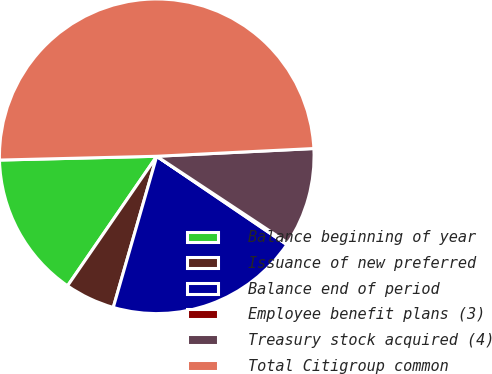Convert chart. <chart><loc_0><loc_0><loc_500><loc_500><pie_chart><fcel>Balance beginning of year<fcel>Issuance of new preferred<fcel>Balance end of period<fcel>Employee benefit plans (3)<fcel>Treasury stock acquired (4)<fcel>Total Citigroup common<nl><fcel>15.02%<fcel>5.14%<fcel>19.96%<fcel>0.2%<fcel>10.08%<fcel>49.6%<nl></chart> 